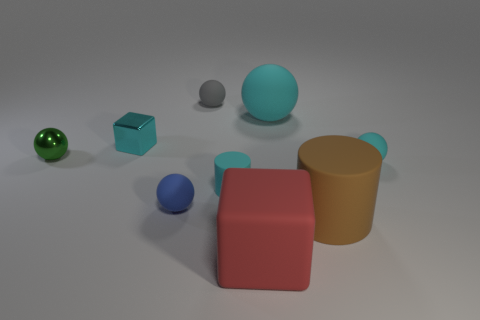Can you describe the lighting in the scene? The scene is softly lit from above, creating gentle shadows on the ground beneath each object. The lighting seems to be diffused, as it does not cause very sharp or high-contrast shadows. 